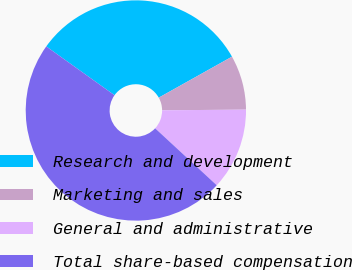Convert chart to OTSL. <chart><loc_0><loc_0><loc_500><loc_500><pie_chart><fcel>Research and development<fcel>Marketing and sales<fcel>General and administrative<fcel>Total share-based compensation<nl><fcel>32.0%<fcel>8.0%<fcel>12.0%<fcel>48.0%<nl></chart> 